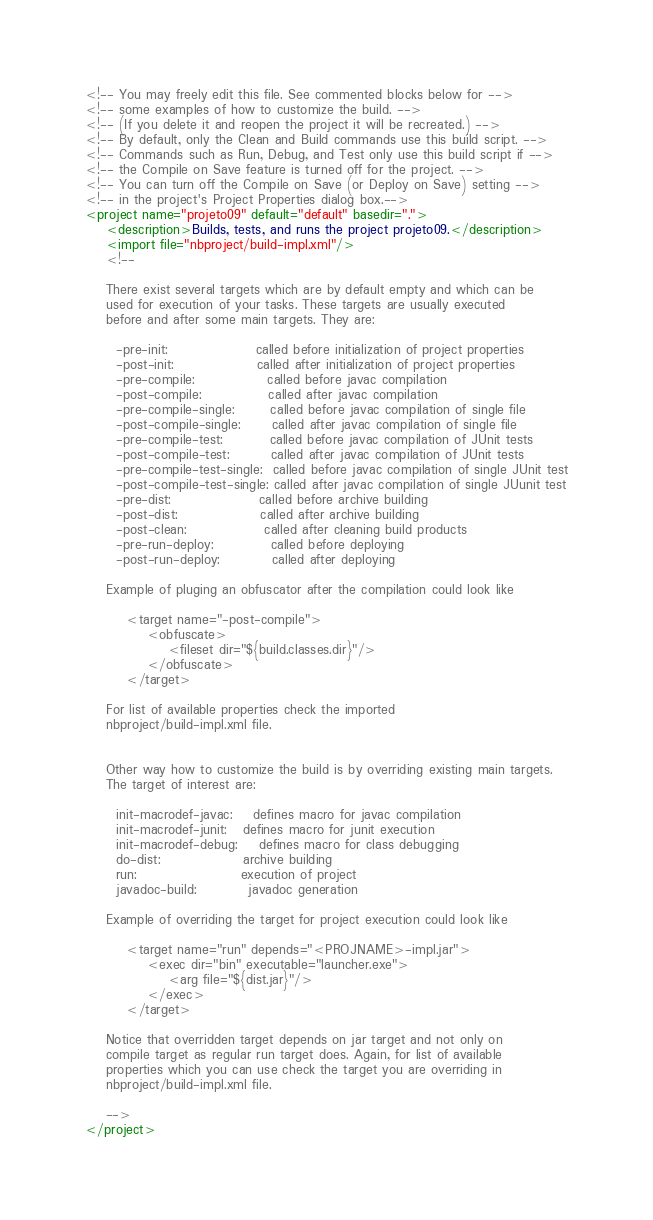<code> <loc_0><loc_0><loc_500><loc_500><_XML_><!-- You may freely edit this file. See commented blocks below for -->
<!-- some examples of how to customize the build. -->
<!-- (If you delete it and reopen the project it will be recreated.) -->
<!-- By default, only the Clean and Build commands use this build script. -->
<!-- Commands such as Run, Debug, and Test only use this build script if -->
<!-- the Compile on Save feature is turned off for the project. -->
<!-- You can turn off the Compile on Save (or Deploy on Save) setting -->
<!-- in the project's Project Properties dialog box.-->
<project name="projeto09" default="default" basedir=".">
    <description>Builds, tests, and runs the project projeto09.</description>
    <import file="nbproject/build-impl.xml"/>
    <!--

    There exist several targets which are by default empty and which can be 
    used for execution of your tasks. These targets are usually executed 
    before and after some main targets. They are: 

      -pre-init:                 called before initialization of project properties 
      -post-init:                called after initialization of project properties 
      -pre-compile:              called before javac compilation 
      -post-compile:             called after javac compilation 
      -pre-compile-single:       called before javac compilation of single file
      -post-compile-single:      called after javac compilation of single file
      -pre-compile-test:         called before javac compilation of JUnit tests
      -post-compile-test:        called after javac compilation of JUnit tests
      -pre-compile-test-single:  called before javac compilation of single JUnit test
      -post-compile-test-single: called after javac compilation of single JUunit test
      -pre-dist:                 called before archive building 
      -post-dist:                called after archive building 
      -post-clean:               called after cleaning build products 
      -pre-run-deploy:           called before deploying
      -post-run-deploy:          called after deploying

    Example of pluging an obfuscator after the compilation could look like 

        <target name="-post-compile">
            <obfuscate>
                <fileset dir="${build.classes.dir}"/>
            </obfuscate>
        </target>

    For list of available properties check the imported 
    nbproject/build-impl.xml file. 


    Other way how to customize the build is by overriding existing main targets.
    The target of interest are: 

      init-macrodef-javac:    defines macro for javac compilation
      init-macrodef-junit:   defines macro for junit execution
      init-macrodef-debug:    defines macro for class debugging
      do-dist:                archive building
      run:                    execution of project 
      javadoc-build:          javadoc generation 

    Example of overriding the target for project execution could look like 

        <target name="run" depends="<PROJNAME>-impl.jar">
            <exec dir="bin" executable="launcher.exe">
                <arg file="${dist.jar}"/>
            </exec>
        </target>

    Notice that overridden target depends on jar target and not only on 
    compile target as regular run target does. Again, for list of available 
    properties which you can use check the target you are overriding in 
    nbproject/build-impl.xml file. 

    -->
</project>
</code> 